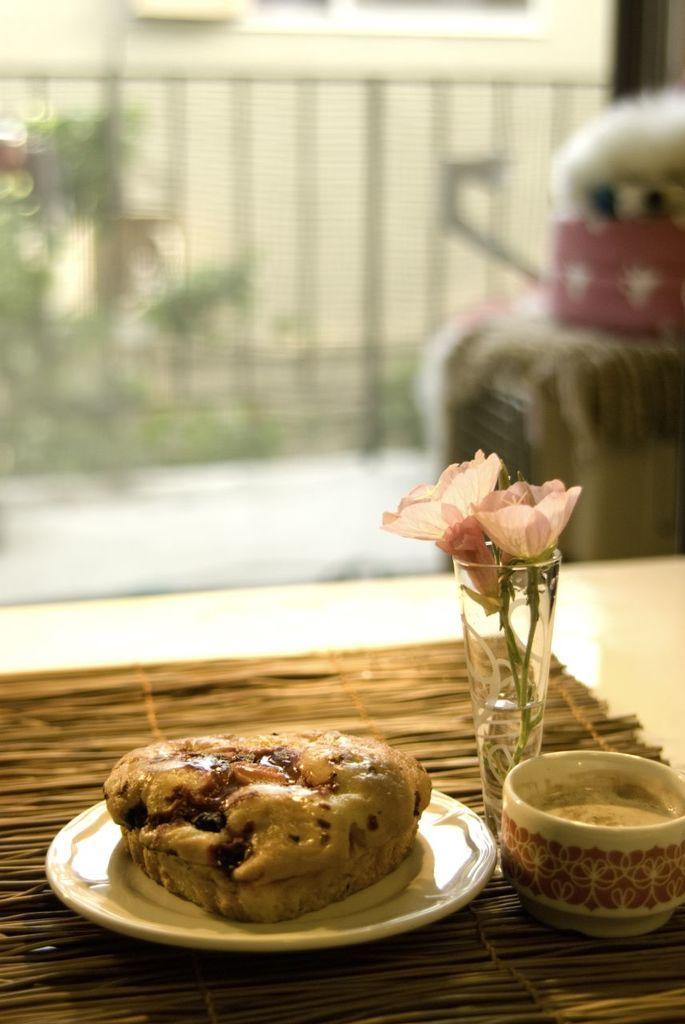Please provide a concise description of this image. In this picture we can see table and on table we have cup with coffee, vase with flower, plate with some food on it and in background we can see fence, dog, tree. 